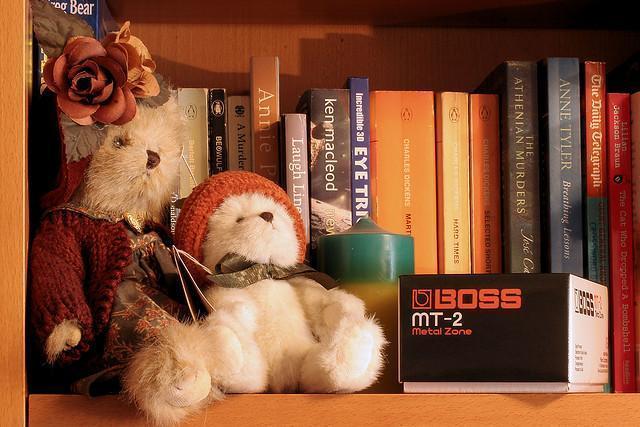How many stuffed animals are there?
Give a very brief answer. 2. How many teddy bears are in the photo?
Give a very brief answer. 2. How many books are there?
Give a very brief answer. 12. 